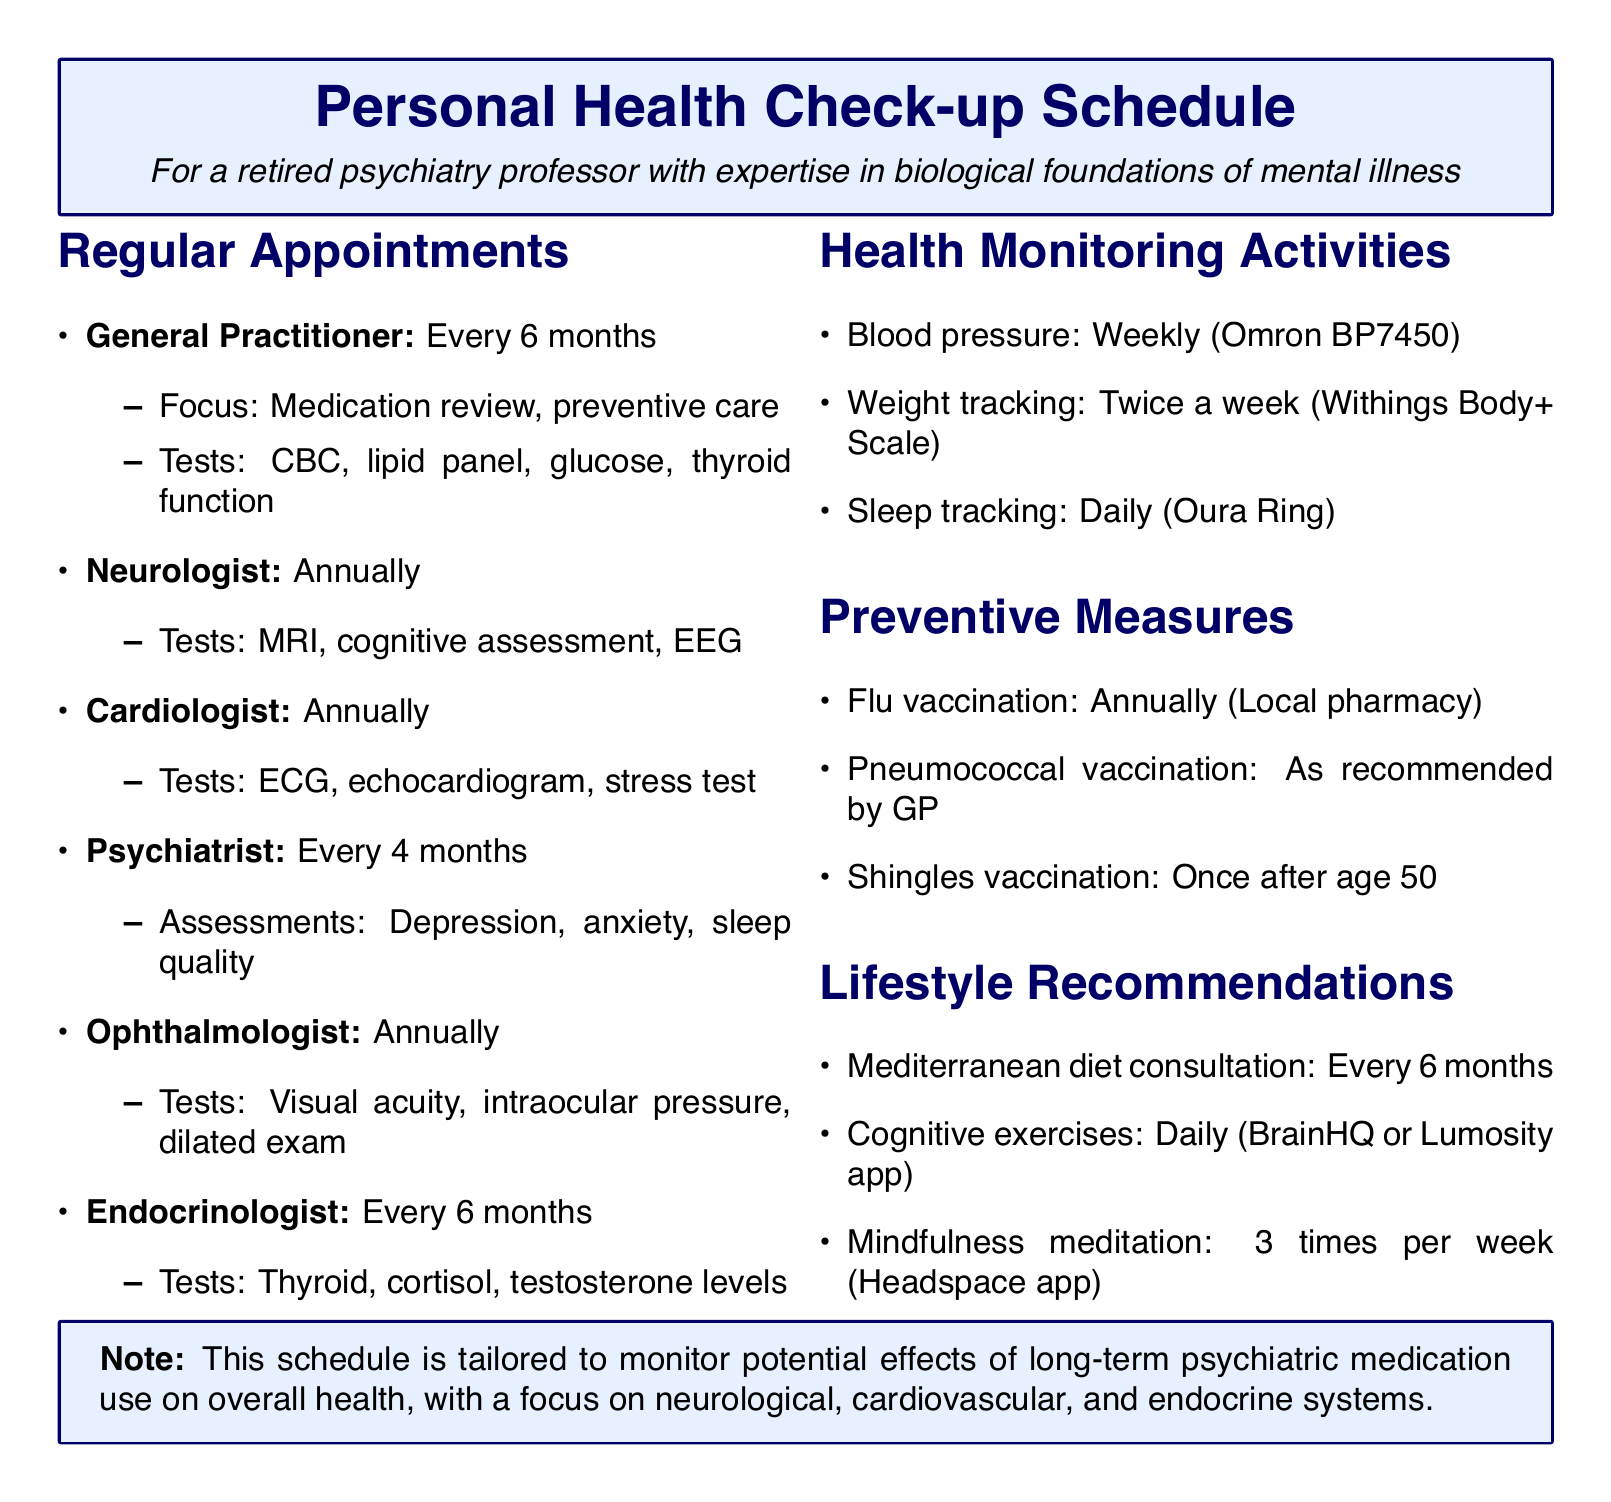What is the frequency of appointments with the general practitioner? The frequency for general practitioner appointments is specified in the document as "Every 6 months".
Answer: Every 6 months What test is recommended by the cardiologist? The document lists "Electrocardiogram (ECG)" as one of the recommended tests by the cardiologist.
Answer: Electrocardiogram (ECG) How often should the neurologist be consulted? The document clearly states that neurologist appointments should be held "Annually".
Answer: Annually What is the purpose of the wellness checks with the psychiatrist? The document outlines the purpose as "Mental health check-up and medication management".
Answer: Mental health check-up and medication management What specific focus of the ophthalmologist's appointments is mentioned? The document indicates the specific focus as "Monitoring for potential ocular side effects of psychiatric medications".
Answer: Monitoring for potential ocular side effects of psychiatric medications How frequently should blood pressure be monitored? The document specifies that blood pressure monitoring should occur "Weekly".
Answer: Weekly What type of vaccination is recommended annually? According to the document, the "Flu vaccination" is recommended annually.
Answer: Flu vaccination Which dietary consultation is mentioned in the lifestyle recommendations? The document notes a consultation for a "Mediterranean diet" every 6 months.
Answer: Mediterranean diet What tool is suggested for daily cognitive exercises? The document recommends using "BrainHQ or Lumosity app" for daily cognitive exercises.
Answer: BrainHQ or Lumosity app What is the specific focus of the endocrinologist's appointments? The document states the specific focus as "Evaluating endocrine system function in relation to mental health and medication effects".
Answer: Evaluating endocrine system function in relation to mental health and medication effects 